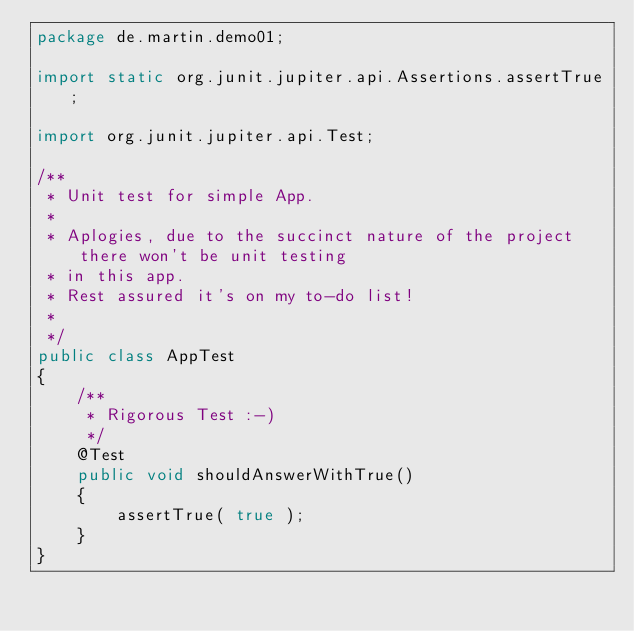Convert code to text. <code><loc_0><loc_0><loc_500><loc_500><_Java_>package de.martin.demo01;

import static org.junit.jupiter.api.Assertions.assertTrue;

import org.junit.jupiter.api.Test;

/**
 * Unit test for simple App.
 * 
 * Aplogies, due to the succinct nature of the project there won't be unit testing
 * in this app.
 * Rest assured it's on my to-do list!
 * 
 */
public class AppTest 
{
    /**
     * Rigorous Test :-)
     */
    @Test
    public void shouldAnswerWithTrue()
    {
        assertTrue( true );
    }
}
</code> 